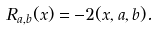Convert formula to latex. <formula><loc_0><loc_0><loc_500><loc_500>R _ { a , b } ( x ) = - 2 ( x , a , b ) .</formula> 